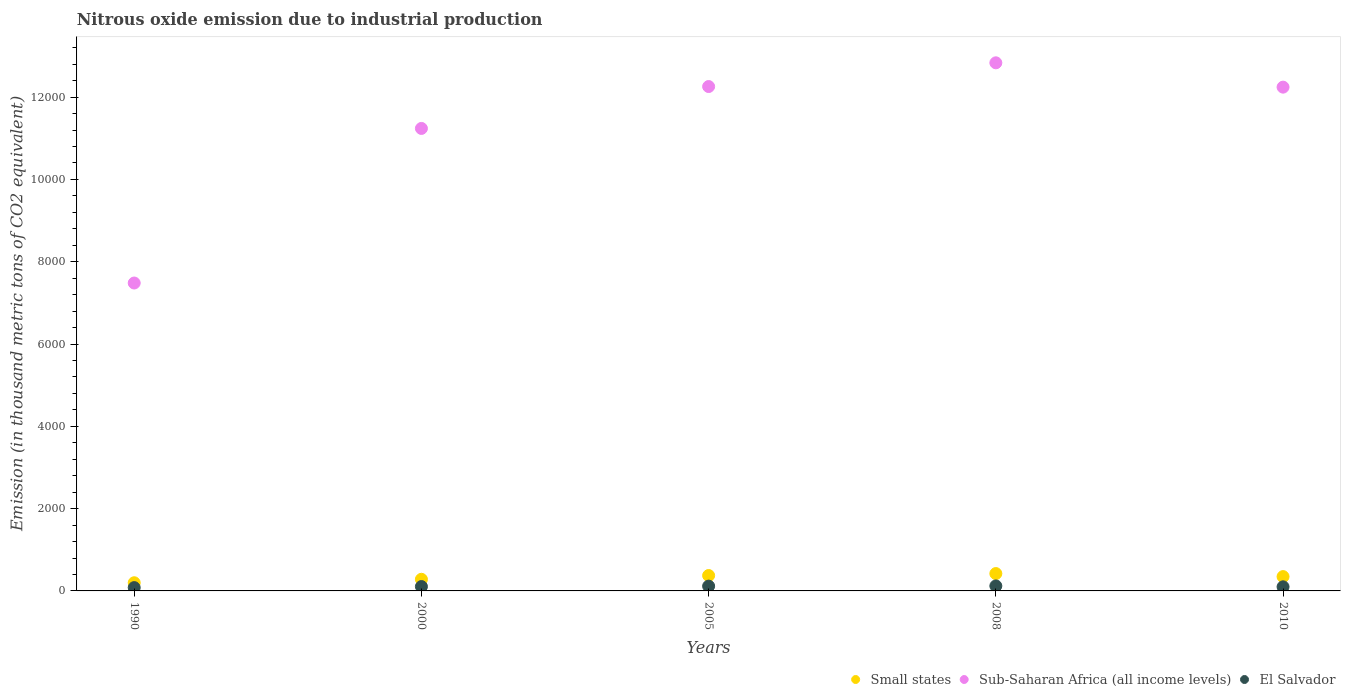How many different coloured dotlines are there?
Provide a succinct answer. 3. What is the amount of nitrous oxide emitted in El Salvador in 2005?
Offer a terse response. 116.5. Across all years, what is the maximum amount of nitrous oxide emitted in Small states?
Ensure brevity in your answer.  421.7. Across all years, what is the minimum amount of nitrous oxide emitted in El Salvador?
Provide a succinct answer. 80.5. In which year was the amount of nitrous oxide emitted in Small states maximum?
Give a very brief answer. 2008. In which year was the amount of nitrous oxide emitted in Small states minimum?
Your answer should be compact. 1990. What is the total amount of nitrous oxide emitted in Sub-Saharan Africa (all income levels) in the graph?
Offer a terse response. 5.61e+04. What is the difference between the amount of nitrous oxide emitted in Sub-Saharan Africa (all income levels) in 1990 and that in 2005?
Your response must be concise. -4774.5. What is the difference between the amount of nitrous oxide emitted in El Salvador in 2005 and the amount of nitrous oxide emitted in Small states in 2010?
Make the answer very short. -231.4. What is the average amount of nitrous oxide emitted in Small states per year?
Your response must be concise. 324.94. In the year 2010, what is the difference between the amount of nitrous oxide emitted in Sub-Saharan Africa (all income levels) and amount of nitrous oxide emitted in Small states?
Keep it short and to the point. 1.19e+04. In how many years, is the amount of nitrous oxide emitted in Small states greater than 2800 thousand metric tons?
Give a very brief answer. 0. What is the ratio of the amount of nitrous oxide emitted in Small states in 2005 to that in 2010?
Keep it short and to the point. 1.08. Is the amount of nitrous oxide emitted in Small states in 1990 less than that in 2008?
Give a very brief answer. Yes. Is the difference between the amount of nitrous oxide emitted in Sub-Saharan Africa (all income levels) in 2005 and 2008 greater than the difference between the amount of nitrous oxide emitted in Small states in 2005 and 2008?
Offer a terse response. No. What is the difference between the highest and the second highest amount of nitrous oxide emitted in Small states?
Keep it short and to the point. 47.7. What is the difference between the highest and the lowest amount of nitrous oxide emitted in Small states?
Make the answer very short. 223.2. Is the amount of nitrous oxide emitted in Small states strictly less than the amount of nitrous oxide emitted in El Salvador over the years?
Provide a short and direct response. No. What is the difference between two consecutive major ticks on the Y-axis?
Give a very brief answer. 2000. Are the values on the major ticks of Y-axis written in scientific E-notation?
Keep it short and to the point. No. Does the graph contain any zero values?
Provide a succinct answer. No. Does the graph contain grids?
Offer a very short reply. No. How many legend labels are there?
Keep it short and to the point. 3. What is the title of the graph?
Your response must be concise. Nitrous oxide emission due to industrial production. Does "South Asia" appear as one of the legend labels in the graph?
Provide a succinct answer. No. What is the label or title of the X-axis?
Your answer should be very brief. Years. What is the label or title of the Y-axis?
Your answer should be very brief. Emission (in thousand metric tons of CO2 equivalent). What is the Emission (in thousand metric tons of CO2 equivalent) in Small states in 1990?
Offer a terse response. 198.5. What is the Emission (in thousand metric tons of CO2 equivalent) of Sub-Saharan Africa (all income levels) in 1990?
Provide a short and direct response. 7482.3. What is the Emission (in thousand metric tons of CO2 equivalent) in El Salvador in 1990?
Give a very brief answer. 80.5. What is the Emission (in thousand metric tons of CO2 equivalent) in Small states in 2000?
Your answer should be compact. 282.6. What is the Emission (in thousand metric tons of CO2 equivalent) in Sub-Saharan Africa (all income levels) in 2000?
Your answer should be compact. 1.12e+04. What is the Emission (in thousand metric tons of CO2 equivalent) of El Salvador in 2000?
Keep it short and to the point. 106. What is the Emission (in thousand metric tons of CO2 equivalent) of Small states in 2005?
Your answer should be very brief. 374. What is the Emission (in thousand metric tons of CO2 equivalent) of Sub-Saharan Africa (all income levels) in 2005?
Keep it short and to the point. 1.23e+04. What is the Emission (in thousand metric tons of CO2 equivalent) in El Salvador in 2005?
Ensure brevity in your answer.  116.5. What is the Emission (in thousand metric tons of CO2 equivalent) of Small states in 2008?
Give a very brief answer. 421.7. What is the Emission (in thousand metric tons of CO2 equivalent) in Sub-Saharan Africa (all income levels) in 2008?
Offer a terse response. 1.28e+04. What is the Emission (in thousand metric tons of CO2 equivalent) in El Salvador in 2008?
Offer a very short reply. 121.2. What is the Emission (in thousand metric tons of CO2 equivalent) in Small states in 2010?
Your answer should be very brief. 347.9. What is the Emission (in thousand metric tons of CO2 equivalent) in Sub-Saharan Africa (all income levels) in 2010?
Ensure brevity in your answer.  1.22e+04. What is the Emission (in thousand metric tons of CO2 equivalent) of El Salvador in 2010?
Give a very brief answer. 99.9. Across all years, what is the maximum Emission (in thousand metric tons of CO2 equivalent) of Small states?
Give a very brief answer. 421.7. Across all years, what is the maximum Emission (in thousand metric tons of CO2 equivalent) of Sub-Saharan Africa (all income levels)?
Your answer should be very brief. 1.28e+04. Across all years, what is the maximum Emission (in thousand metric tons of CO2 equivalent) in El Salvador?
Your answer should be very brief. 121.2. Across all years, what is the minimum Emission (in thousand metric tons of CO2 equivalent) of Small states?
Ensure brevity in your answer.  198.5. Across all years, what is the minimum Emission (in thousand metric tons of CO2 equivalent) of Sub-Saharan Africa (all income levels)?
Provide a short and direct response. 7482.3. Across all years, what is the minimum Emission (in thousand metric tons of CO2 equivalent) in El Salvador?
Offer a terse response. 80.5. What is the total Emission (in thousand metric tons of CO2 equivalent) in Small states in the graph?
Offer a terse response. 1624.7. What is the total Emission (in thousand metric tons of CO2 equivalent) in Sub-Saharan Africa (all income levels) in the graph?
Your answer should be very brief. 5.61e+04. What is the total Emission (in thousand metric tons of CO2 equivalent) in El Salvador in the graph?
Your answer should be compact. 524.1. What is the difference between the Emission (in thousand metric tons of CO2 equivalent) in Small states in 1990 and that in 2000?
Make the answer very short. -84.1. What is the difference between the Emission (in thousand metric tons of CO2 equivalent) in Sub-Saharan Africa (all income levels) in 1990 and that in 2000?
Give a very brief answer. -3756.4. What is the difference between the Emission (in thousand metric tons of CO2 equivalent) in El Salvador in 1990 and that in 2000?
Your response must be concise. -25.5. What is the difference between the Emission (in thousand metric tons of CO2 equivalent) in Small states in 1990 and that in 2005?
Ensure brevity in your answer.  -175.5. What is the difference between the Emission (in thousand metric tons of CO2 equivalent) of Sub-Saharan Africa (all income levels) in 1990 and that in 2005?
Make the answer very short. -4774.5. What is the difference between the Emission (in thousand metric tons of CO2 equivalent) of El Salvador in 1990 and that in 2005?
Keep it short and to the point. -36. What is the difference between the Emission (in thousand metric tons of CO2 equivalent) in Small states in 1990 and that in 2008?
Make the answer very short. -223.2. What is the difference between the Emission (in thousand metric tons of CO2 equivalent) in Sub-Saharan Africa (all income levels) in 1990 and that in 2008?
Make the answer very short. -5351.1. What is the difference between the Emission (in thousand metric tons of CO2 equivalent) of El Salvador in 1990 and that in 2008?
Your answer should be compact. -40.7. What is the difference between the Emission (in thousand metric tons of CO2 equivalent) in Small states in 1990 and that in 2010?
Your answer should be very brief. -149.4. What is the difference between the Emission (in thousand metric tons of CO2 equivalent) in Sub-Saharan Africa (all income levels) in 1990 and that in 2010?
Your response must be concise. -4759.9. What is the difference between the Emission (in thousand metric tons of CO2 equivalent) of El Salvador in 1990 and that in 2010?
Your answer should be compact. -19.4. What is the difference between the Emission (in thousand metric tons of CO2 equivalent) of Small states in 2000 and that in 2005?
Provide a succinct answer. -91.4. What is the difference between the Emission (in thousand metric tons of CO2 equivalent) in Sub-Saharan Africa (all income levels) in 2000 and that in 2005?
Offer a terse response. -1018.1. What is the difference between the Emission (in thousand metric tons of CO2 equivalent) of Small states in 2000 and that in 2008?
Make the answer very short. -139.1. What is the difference between the Emission (in thousand metric tons of CO2 equivalent) of Sub-Saharan Africa (all income levels) in 2000 and that in 2008?
Offer a very short reply. -1594.7. What is the difference between the Emission (in thousand metric tons of CO2 equivalent) in El Salvador in 2000 and that in 2008?
Keep it short and to the point. -15.2. What is the difference between the Emission (in thousand metric tons of CO2 equivalent) of Small states in 2000 and that in 2010?
Make the answer very short. -65.3. What is the difference between the Emission (in thousand metric tons of CO2 equivalent) of Sub-Saharan Africa (all income levels) in 2000 and that in 2010?
Offer a very short reply. -1003.5. What is the difference between the Emission (in thousand metric tons of CO2 equivalent) in Small states in 2005 and that in 2008?
Make the answer very short. -47.7. What is the difference between the Emission (in thousand metric tons of CO2 equivalent) in Sub-Saharan Africa (all income levels) in 2005 and that in 2008?
Your answer should be very brief. -576.6. What is the difference between the Emission (in thousand metric tons of CO2 equivalent) in Small states in 2005 and that in 2010?
Your answer should be very brief. 26.1. What is the difference between the Emission (in thousand metric tons of CO2 equivalent) in Sub-Saharan Africa (all income levels) in 2005 and that in 2010?
Keep it short and to the point. 14.6. What is the difference between the Emission (in thousand metric tons of CO2 equivalent) in Small states in 2008 and that in 2010?
Ensure brevity in your answer.  73.8. What is the difference between the Emission (in thousand metric tons of CO2 equivalent) in Sub-Saharan Africa (all income levels) in 2008 and that in 2010?
Offer a very short reply. 591.2. What is the difference between the Emission (in thousand metric tons of CO2 equivalent) of El Salvador in 2008 and that in 2010?
Your response must be concise. 21.3. What is the difference between the Emission (in thousand metric tons of CO2 equivalent) in Small states in 1990 and the Emission (in thousand metric tons of CO2 equivalent) in Sub-Saharan Africa (all income levels) in 2000?
Provide a short and direct response. -1.10e+04. What is the difference between the Emission (in thousand metric tons of CO2 equivalent) of Small states in 1990 and the Emission (in thousand metric tons of CO2 equivalent) of El Salvador in 2000?
Keep it short and to the point. 92.5. What is the difference between the Emission (in thousand metric tons of CO2 equivalent) of Sub-Saharan Africa (all income levels) in 1990 and the Emission (in thousand metric tons of CO2 equivalent) of El Salvador in 2000?
Give a very brief answer. 7376.3. What is the difference between the Emission (in thousand metric tons of CO2 equivalent) in Small states in 1990 and the Emission (in thousand metric tons of CO2 equivalent) in Sub-Saharan Africa (all income levels) in 2005?
Make the answer very short. -1.21e+04. What is the difference between the Emission (in thousand metric tons of CO2 equivalent) of Small states in 1990 and the Emission (in thousand metric tons of CO2 equivalent) of El Salvador in 2005?
Offer a very short reply. 82. What is the difference between the Emission (in thousand metric tons of CO2 equivalent) of Sub-Saharan Africa (all income levels) in 1990 and the Emission (in thousand metric tons of CO2 equivalent) of El Salvador in 2005?
Provide a short and direct response. 7365.8. What is the difference between the Emission (in thousand metric tons of CO2 equivalent) in Small states in 1990 and the Emission (in thousand metric tons of CO2 equivalent) in Sub-Saharan Africa (all income levels) in 2008?
Offer a terse response. -1.26e+04. What is the difference between the Emission (in thousand metric tons of CO2 equivalent) of Small states in 1990 and the Emission (in thousand metric tons of CO2 equivalent) of El Salvador in 2008?
Your response must be concise. 77.3. What is the difference between the Emission (in thousand metric tons of CO2 equivalent) in Sub-Saharan Africa (all income levels) in 1990 and the Emission (in thousand metric tons of CO2 equivalent) in El Salvador in 2008?
Offer a terse response. 7361.1. What is the difference between the Emission (in thousand metric tons of CO2 equivalent) in Small states in 1990 and the Emission (in thousand metric tons of CO2 equivalent) in Sub-Saharan Africa (all income levels) in 2010?
Give a very brief answer. -1.20e+04. What is the difference between the Emission (in thousand metric tons of CO2 equivalent) of Small states in 1990 and the Emission (in thousand metric tons of CO2 equivalent) of El Salvador in 2010?
Keep it short and to the point. 98.6. What is the difference between the Emission (in thousand metric tons of CO2 equivalent) in Sub-Saharan Africa (all income levels) in 1990 and the Emission (in thousand metric tons of CO2 equivalent) in El Salvador in 2010?
Offer a terse response. 7382.4. What is the difference between the Emission (in thousand metric tons of CO2 equivalent) in Small states in 2000 and the Emission (in thousand metric tons of CO2 equivalent) in Sub-Saharan Africa (all income levels) in 2005?
Make the answer very short. -1.20e+04. What is the difference between the Emission (in thousand metric tons of CO2 equivalent) in Small states in 2000 and the Emission (in thousand metric tons of CO2 equivalent) in El Salvador in 2005?
Keep it short and to the point. 166.1. What is the difference between the Emission (in thousand metric tons of CO2 equivalent) of Sub-Saharan Africa (all income levels) in 2000 and the Emission (in thousand metric tons of CO2 equivalent) of El Salvador in 2005?
Your response must be concise. 1.11e+04. What is the difference between the Emission (in thousand metric tons of CO2 equivalent) of Small states in 2000 and the Emission (in thousand metric tons of CO2 equivalent) of Sub-Saharan Africa (all income levels) in 2008?
Provide a short and direct response. -1.26e+04. What is the difference between the Emission (in thousand metric tons of CO2 equivalent) in Small states in 2000 and the Emission (in thousand metric tons of CO2 equivalent) in El Salvador in 2008?
Keep it short and to the point. 161.4. What is the difference between the Emission (in thousand metric tons of CO2 equivalent) in Sub-Saharan Africa (all income levels) in 2000 and the Emission (in thousand metric tons of CO2 equivalent) in El Salvador in 2008?
Offer a very short reply. 1.11e+04. What is the difference between the Emission (in thousand metric tons of CO2 equivalent) of Small states in 2000 and the Emission (in thousand metric tons of CO2 equivalent) of Sub-Saharan Africa (all income levels) in 2010?
Give a very brief answer. -1.20e+04. What is the difference between the Emission (in thousand metric tons of CO2 equivalent) in Small states in 2000 and the Emission (in thousand metric tons of CO2 equivalent) in El Salvador in 2010?
Keep it short and to the point. 182.7. What is the difference between the Emission (in thousand metric tons of CO2 equivalent) of Sub-Saharan Africa (all income levels) in 2000 and the Emission (in thousand metric tons of CO2 equivalent) of El Salvador in 2010?
Provide a short and direct response. 1.11e+04. What is the difference between the Emission (in thousand metric tons of CO2 equivalent) in Small states in 2005 and the Emission (in thousand metric tons of CO2 equivalent) in Sub-Saharan Africa (all income levels) in 2008?
Your answer should be compact. -1.25e+04. What is the difference between the Emission (in thousand metric tons of CO2 equivalent) in Small states in 2005 and the Emission (in thousand metric tons of CO2 equivalent) in El Salvador in 2008?
Provide a short and direct response. 252.8. What is the difference between the Emission (in thousand metric tons of CO2 equivalent) in Sub-Saharan Africa (all income levels) in 2005 and the Emission (in thousand metric tons of CO2 equivalent) in El Salvador in 2008?
Keep it short and to the point. 1.21e+04. What is the difference between the Emission (in thousand metric tons of CO2 equivalent) of Small states in 2005 and the Emission (in thousand metric tons of CO2 equivalent) of Sub-Saharan Africa (all income levels) in 2010?
Provide a short and direct response. -1.19e+04. What is the difference between the Emission (in thousand metric tons of CO2 equivalent) of Small states in 2005 and the Emission (in thousand metric tons of CO2 equivalent) of El Salvador in 2010?
Offer a very short reply. 274.1. What is the difference between the Emission (in thousand metric tons of CO2 equivalent) in Sub-Saharan Africa (all income levels) in 2005 and the Emission (in thousand metric tons of CO2 equivalent) in El Salvador in 2010?
Give a very brief answer. 1.22e+04. What is the difference between the Emission (in thousand metric tons of CO2 equivalent) in Small states in 2008 and the Emission (in thousand metric tons of CO2 equivalent) in Sub-Saharan Africa (all income levels) in 2010?
Your answer should be compact. -1.18e+04. What is the difference between the Emission (in thousand metric tons of CO2 equivalent) in Small states in 2008 and the Emission (in thousand metric tons of CO2 equivalent) in El Salvador in 2010?
Make the answer very short. 321.8. What is the difference between the Emission (in thousand metric tons of CO2 equivalent) in Sub-Saharan Africa (all income levels) in 2008 and the Emission (in thousand metric tons of CO2 equivalent) in El Salvador in 2010?
Provide a succinct answer. 1.27e+04. What is the average Emission (in thousand metric tons of CO2 equivalent) in Small states per year?
Offer a very short reply. 324.94. What is the average Emission (in thousand metric tons of CO2 equivalent) of Sub-Saharan Africa (all income levels) per year?
Give a very brief answer. 1.12e+04. What is the average Emission (in thousand metric tons of CO2 equivalent) of El Salvador per year?
Offer a terse response. 104.82. In the year 1990, what is the difference between the Emission (in thousand metric tons of CO2 equivalent) of Small states and Emission (in thousand metric tons of CO2 equivalent) of Sub-Saharan Africa (all income levels)?
Make the answer very short. -7283.8. In the year 1990, what is the difference between the Emission (in thousand metric tons of CO2 equivalent) in Small states and Emission (in thousand metric tons of CO2 equivalent) in El Salvador?
Offer a terse response. 118. In the year 1990, what is the difference between the Emission (in thousand metric tons of CO2 equivalent) of Sub-Saharan Africa (all income levels) and Emission (in thousand metric tons of CO2 equivalent) of El Salvador?
Offer a very short reply. 7401.8. In the year 2000, what is the difference between the Emission (in thousand metric tons of CO2 equivalent) of Small states and Emission (in thousand metric tons of CO2 equivalent) of Sub-Saharan Africa (all income levels)?
Ensure brevity in your answer.  -1.10e+04. In the year 2000, what is the difference between the Emission (in thousand metric tons of CO2 equivalent) of Small states and Emission (in thousand metric tons of CO2 equivalent) of El Salvador?
Keep it short and to the point. 176.6. In the year 2000, what is the difference between the Emission (in thousand metric tons of CO2 equivalent) of Sub-Saharan Africa (all income levels) and Emission (in thousand metric tons of CO2 equivalent) of El Salvador?
Keep it short and to the point. 1.11e+04. In the year 2005, what is the difference between the Emission (in thousand metric tons of CO2 equivalent) of Small states and Emission (in thousand metric tons of CO2 equivalent) of Sub-Saharan Africa (all income levels)?
Your response must be concise. -1.19e+04. In the year 2005, what is the difference between the Emission (in thousand metric tons of CO2 equivalent) of Small states and Emission (in thousand metric tons of CO2 equivalent) of El Salvador?
Give a very brief answer. 257.5. In the year 2005, what is the difference between the Emission (in thousand metric tons of CO2 equivalent) of Sub-Saharan Africa (all income levels) and Emission (in thousand metric tons of CO2 equivalent) of El Salvador?
Offer a very short reply. 1.21e+04. In the year 2008, what is the difference between the Emission (in thousand metric tons of CO2 equivalent) in Small states and Emission (in thousand metric tons of CO2 equivalent) in Sub-Saharan Africa (all income levels)?
Make the answer very short. -1.24e+04. In the year 2008, what is the difference between the Emission (in thousand metric tons of CO2 equivalent) in Small states and Emission (in thousand metric tons of CO2 equivalent) in El Salvador?
Provide a short and direct response. 300.5. In the year 2008, what is the difference between the Emission (in thousand metric tons of CO2 equivalent) in Sub-Saharan Africa (all income levels) and Emission (in thousand metric tons of CO2 equivalent) in El Salvador?
Give a very brief answer. 1.27e+04. In the year 2010, what is the difference between the Emission (in thousand metric tons of CO2 equivalent) of Small states and Emission (in thousand metric tons of CO2 equivalent) of Sub-Saharan Africa (all income levels)?
Offer a very short reply. -1.19e+04. In the year 2010, what is the difference between the Emission (in thousand metric tons of CO2 equivalent) of Small states and Emission (in thousand metric tons of CO2 equivalent) of El Salvador?
Your response must be concise. 248. In the year 2010, what is the difference between the Emission (in thousand metric tons of CO2 equivalent) in Sub-Saharan Africa (all income levels) and Emission (in thousand metric tons of CO2 equivalent) in El Salvador?
Your answer should be compact. 1.21e+04. What is the ratio of the Emission (in thousand metric tons of CO2 equivalent) of Small states in 1990 to that in 2000?
Offer a terse response. 0.7. What is the ratio of the Emission (in thousand metric tons of CO2 equivalent) of Sub-Saharan Africa (all income levels) in 1990 to that in 2000?
Your answer should be compact. 0.67. What is the ratio of the Emission (in thousand metric tons of CO2 equivalent) of El Salvador in 1990 to that in 2000?
Your response must be concise. 0.76. What is the ratio of the Emission (in thousand metric tons of CO2 equivalent) of Small states in 1990 to that in 2005?
Give a very brief answer. 0.53. What is the ratio of the Emission (in thousand metric tons of CO2 equivalent) in Sub-Saharan Africa (all income levels) in 1990 to that in 2005?
Keep it short and to the point. 0.61. What is the ratio of the Emission (in thousand metric tons of CO2 equivalent) of El Salvador in 1990 to that in 2005?
Make the answer very short. 0.69. What is the ratio of the Emission (in thousand metric tons of CO2 equivalent) of Small states in 1990 to that in 2008?
Offer a very short reply. 0.47. What is the ratio of the Emission (in thousand metric tons of CO2 equivalent) in Sub-Saharan Africa (all income levels) in 1990 to that in 2008?
Keep it short and to the point. 0.58. What is the ratio of the Emission (in thousand metric tons of CO2 equivalent) in El Salvador in 1990 to that in 2008?
Provide a short and direct response. 0.66. What is the ratio of the Emission (in thousand metric tons of CO2 equivalent) in Small states in 1990 to that in 2010?
Provide a short and direct response. 0.57. What is the ratio of the Emission (in thousand metric tons of CO2 equivalent) of Sub-Saharan Africa (all income levels) in 1990 to that in 2010?
Give a very brief answer. 0.61. What is the ratio of the Emission (in thousand metric tons of CO2 equivalent) of El Salvador in 1990 to that in 2010?
Your response must be concise. 0.81. What is the ratio of the Emission (in thousand metric tons of CO2 equivalent) in Small states in 2000 to that in 2005?
Ensure brevity in your answer.  0.76. What is the ratio of the Emission (in thousand metric tons of CO2 equivalent) in Sub-Saharan Africa (all income levels) in 2000 to that in 2005?
Give a very brief answer. 0.92. What is the ratio of the Emission (in thousand metric tons of CO2 equivalent) in El Salvador in 2000 to that in 2005?
Offer a terse response. 0.91. What is the ratio of the Emission (in thousand metric tons of CO2 equivalent) of Small states in 2000 to that in 2008?
Your response must be concise. 0.67. What is the ratio of the Emission (in thousand metric tons of CO2 equivalent) of Sub-Saharan Africa (all income levels) in 2000 to that in 2008?
Offer a very short reply. 0.88. What is the ratio of the Emission (in thousand metric tons of CO2 equivalent) in El Salvador in 2000 to that in 2008?
Your answer should be compact. 0.87. What is the ratio of the Emission (in thousand metric tons of CO2 equivalent) in Small states in 2000 to that in 2010?
Offer a terse response. 0.81. What is the ratio of the Emission (in thousand metric tons of CO2 equivalent) of Sub-Saharan Africa (all income levels) in 2000 to that in 2010?
Offer a terse response. 0.92. What is the ratio of the Emission (in thousand metric tons of CO2 equivalent) in El Salvador in 2000 to that in 2010?
Make the answer very short. 1.06. What is the ratio of the Emission (in thousand metric tons of CO2 equivalent) of Small states in 2005 to that in 2008?
Keep it short and to the point. 0.89. What is the ratio of the Emission (in thousand metric tons of CO2 equivalent) in Sub-Saharan Africa (all income levels) in 2005 to that in 2008?
Provide a short and direct response. 0.96. What is the ratio of the Emission (in thousand metric tons of CO2 equivalent) in El Salvador in 2005 to that in 2008?
Provide a short and direct response. 0.96. What is the ratio of the Emission (in thousand metric tons of CO2 equivalent) of Small states in 2005 to that in 2010?
Your response must be concise. 1.07. What is the ratio of the Emission (in thousand metric tons of CO2 equivalent) of El Salvador in 2005 to that in 2010?
Provide a succinct answer. 1.17. What is the ratio of the Emission (in thousand metric tons of CO2 equivalent) of Small states in 2008 to that in 2010?
Your answer should be compact. 1.21. What is the ratio of the Emission (in thousand metric tons of CO2 equivalent) of Sub-Saharan Africa (all income levels) in 2008 to that in 2010?
Your answer should be very brief. 1.05. What is the ratio of the Emission (in thousand metric tons of CO2 equivalent) in El Salvador in 2008 to that in 2010?
Offer a very short reply. 1.21. What is the difference between the highest and the second highest Emission (in thousand metric tons of CO2 equivalent) of Small states?
Offer a terse response. 47.7. What is the difference between the highest and the second highest Emission (in thousand metric tons of CO2 equivalent) of Sub-Saharan Africa (all income levels)?
Make the answer very short. 576.6. What is the difference between the highest and the second highest Emission (in thousand metric tons of CO2 equivalent) of El Salvador?
Provide a succinct answer. 4.7. What is the difference between the highest and the lowest Emission (in thousand metric tons of CO2 equivalent) of Small states?
Offer a terse response. 223.2. What is the difference between the highest and the lowest Emission (in thousand metric tons of CO2 equivalent) of Sub-Saharan Africa (all income levels)?
Offer a terse response. 5351.1. What is the difference between the highest and the lowest Emission (in thousand metric tons of CO2 equivalent) of El Salvador?
Keep it short and to the point. 40.7. 